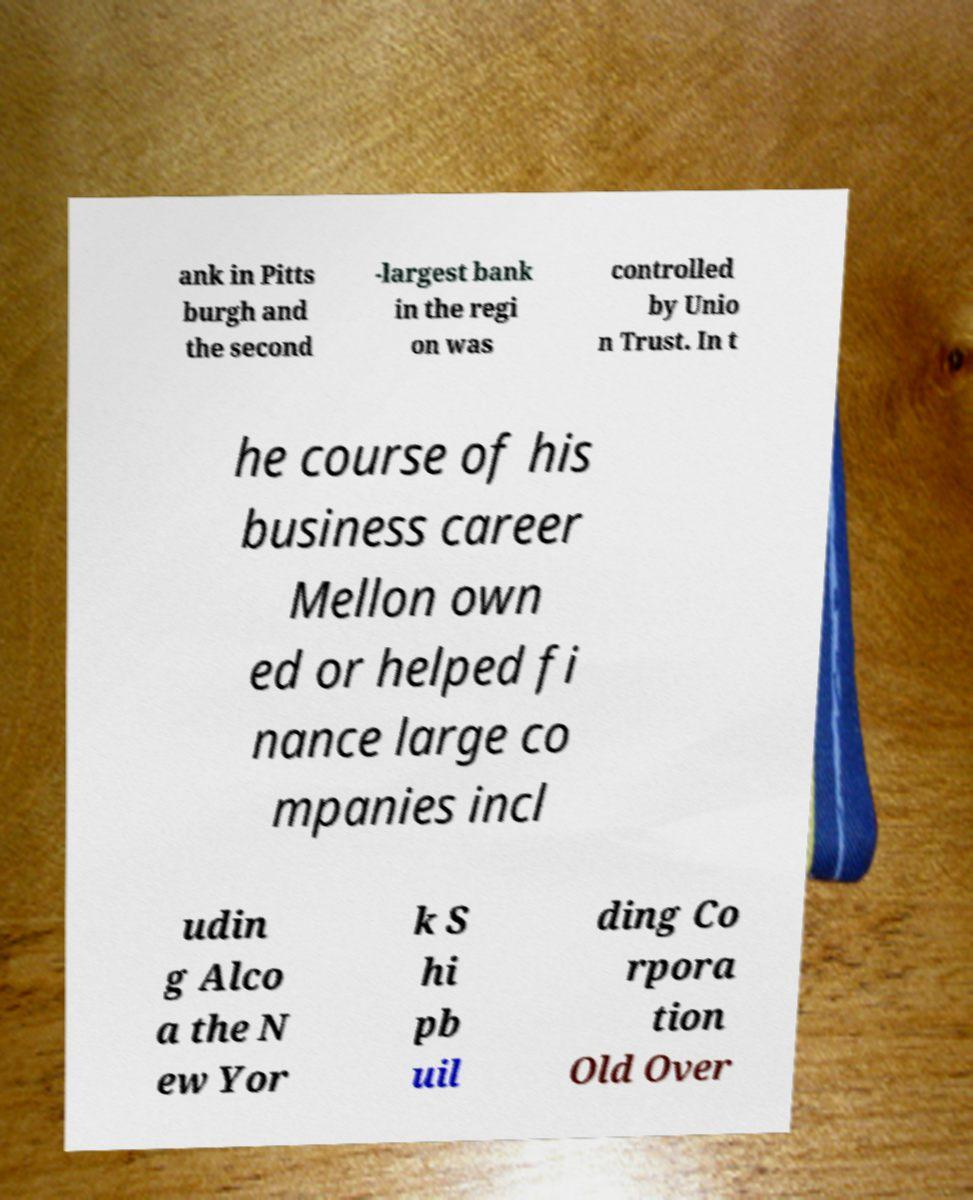For documentation purposes, I need the text within this image transcribed. Could you provide that? ank in Pitts burgh and the second -largest bank in the regi on was controlled by Unio n Trust. In t he course of his business career Mellon own ed or helped fi nance large co mpanies incl udin g Alco a the N ew Yor k S hi pb uil ding Co rpora tion Old Over 